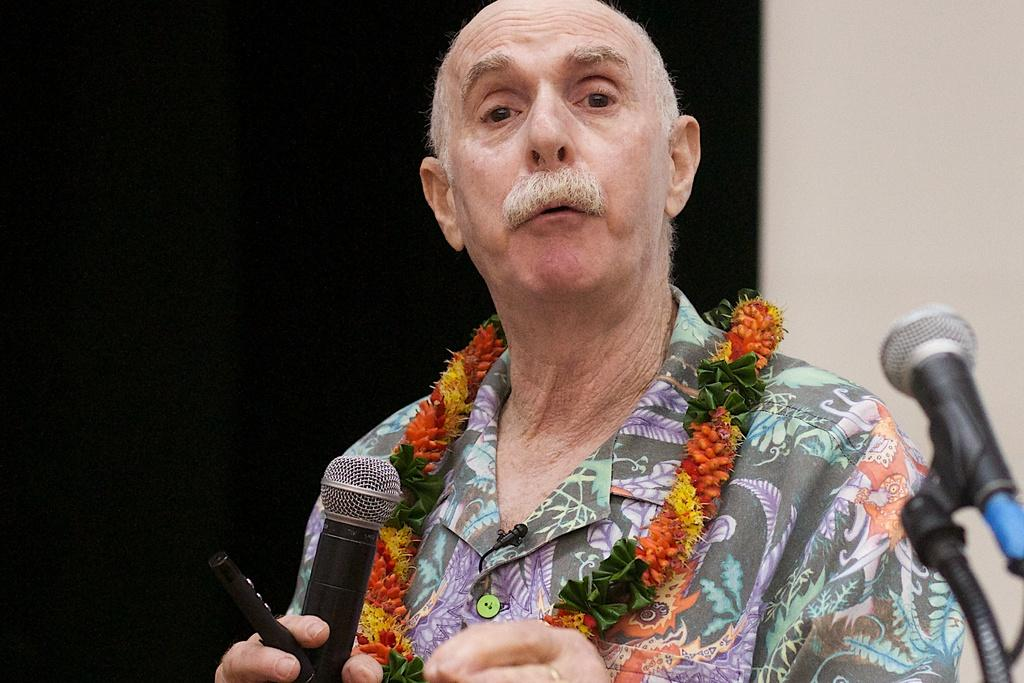Who is present in the image? There is a man in the image. What is the man doing in the image? The man is talking. What is the man wearing in the image? The man is wearing a garland. What is the man holding in the image? The man is holding an object. What can be seen in the image that is used for amplifying sound? There are microphones in the image. What is visible in the image that separates the space? There is a wall in the image. What is the color of the background in the image? The background of the image is dark. What type of flowers can be seen growing on the wall in the image? There are no flowers visible on the wall in the image. How many people are present in the image, and who is the second person? There is only one person, the man, present in the image. What type of jam is the man eating in the image? There is no jam present in the image. 